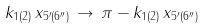<formula> <loc_0><loc_0><loc_500><loc_500>k _ { 1 ( 2 ) } \, x _ { 5 ^ { \prime } ( 6 ^ { \prime \prime } ) } \, \rightarrow \, \pi - k _ { 1 ( 2 ) } \, x _ { 5 ^ { \prime } ( 6 ^ { \prime \prime } ) }</formula> 